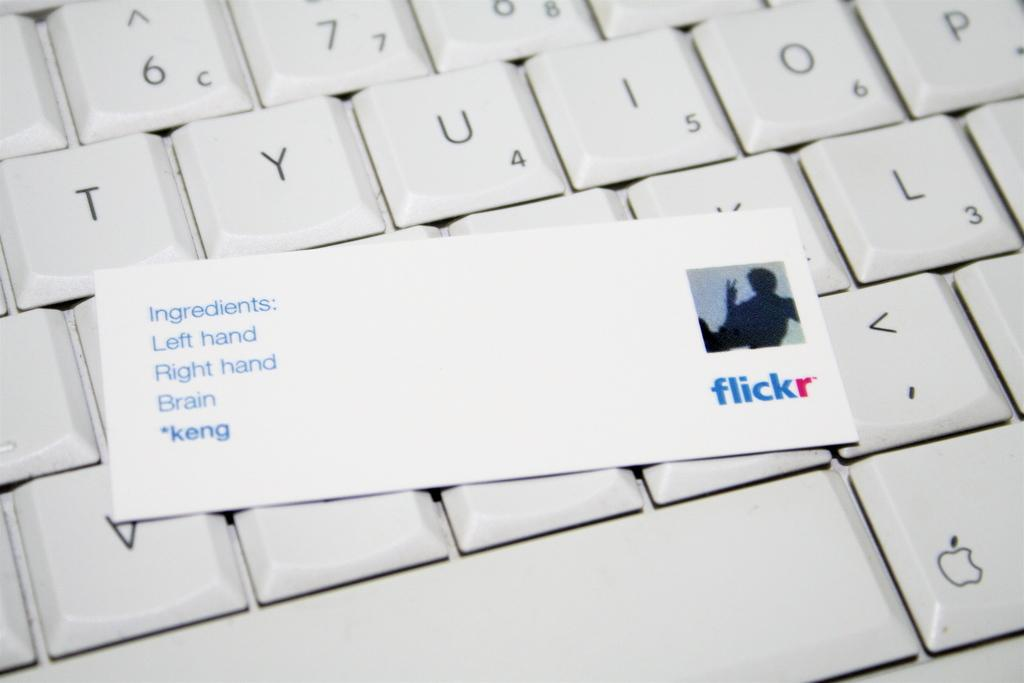<image>
Give a short and clear explanation of the subsequent image. Flickr business card on top of a white Macbook. 